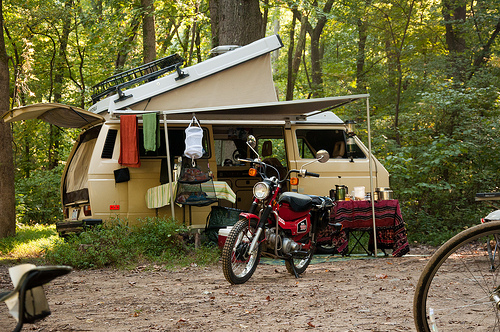<image>
Is there a camper next to the motorcycle? No. The camper is not positioned next to the motorcycle. They are located in different areas of the scene. 